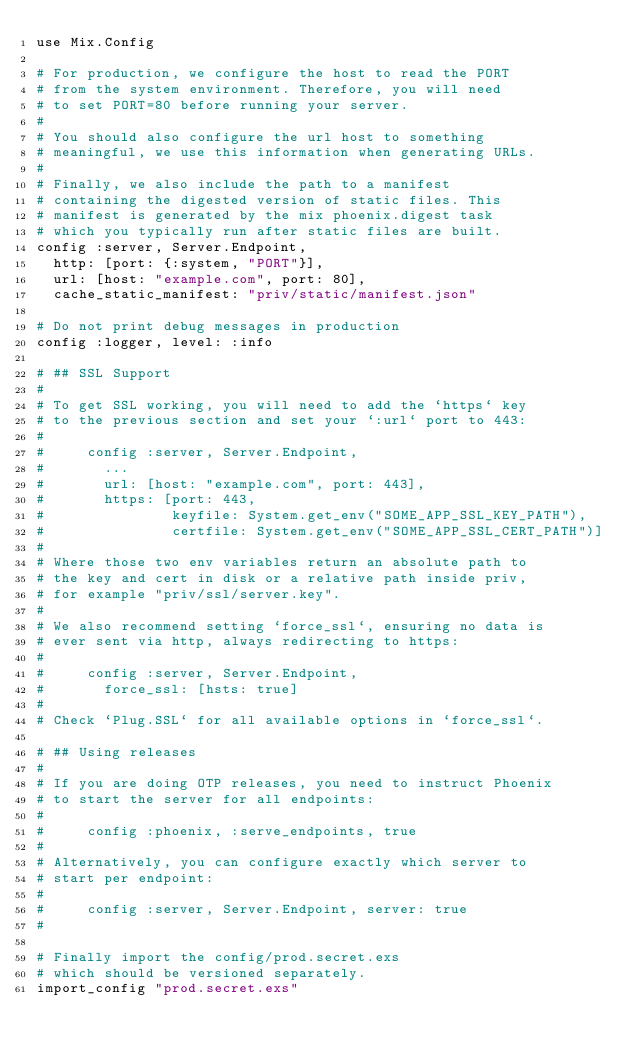Convert code to text. <code><loc_0><loc_0><loc_500><loc_500><_Elixir_>use Mix.Config

# For production, we configure the host to read the PORT
# from the system environment. Therefore, you will need
# to set PORT=80 before running your server.
#
# You should also configure the url host to something
# meaningful, we use this information when generating URLs.
#
# Finally, we also include the path to a manifest
# containing the digested version of static files. This
# manifest is generated by the mix phoenix.digest task
# which you typically run after static files are built.
config :server, Server.Endpoint,
  http: [port: {:system, "PORT"}],
  url: [host: "example.com", port: 80],
  cache_static_manifest: "priv/static/manifest.json"

# Do not print debug messages in production
config :logger, level: :info

# ## SSL Support
#
# To get SSL working, you will need to add the `https` key
# to the previous section and set your `:url` port to 443:
#
#     config :server, Server.Endpoint,
#       ...
#       url: [host: "example.com", port: 443],
#       https: [port: 443,
#               keyfile: System.get_env("SOME_APP_SSL_KEY_PATH"),
#               certfile: System.get_env("SOME_APP_SSL_CERT_PATH")]
#
# Where those two env variables return an absolute path to
# the key and cert in disk or a relative path inside priv,
# for example "priv/ssl/server.key".
#
# We also recommend setting `force_ssl`, ensuring no data is
# ever sent via http, always redirecting to https:
#
#     config :server, Server.Endpoint,
#       force_ssl: [hsts: true]
#
# Check `Plug.SSL` for all available options in `force_ssl`.

# ## Using releases
#
# If you are doing OTP releases, you need to instruct Phoenix
# to start the server for all endpoints:
#
#     config :phoenix, :serve_endpoints, true
#
# Alternatively, you can configure exactly which server to
# start per endpoint:
#
#     config :server, Server.Endpoint, server: true
#

# Finally import the config/prod.secret.exs
# which should be versioned separately.
import_config "prod.secret.exs"
</code> 